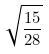<formula> <loc_0><loc_0><loc_500><loc_500>\sqrt { \frac { 1 5 } { 2 8 } }</formula> 